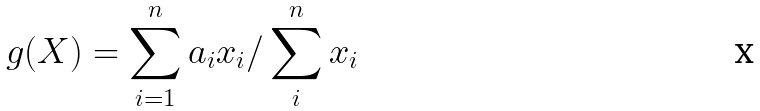Convert formula to latex. <formula><loc_0><loc_0><loc_500><loc_500>g ( X ) = \sum _ { i = 1 } ^ { n } a _ { i } x _ { i } / \sum _ { i } ^ { n } x _ { i }</formula> 